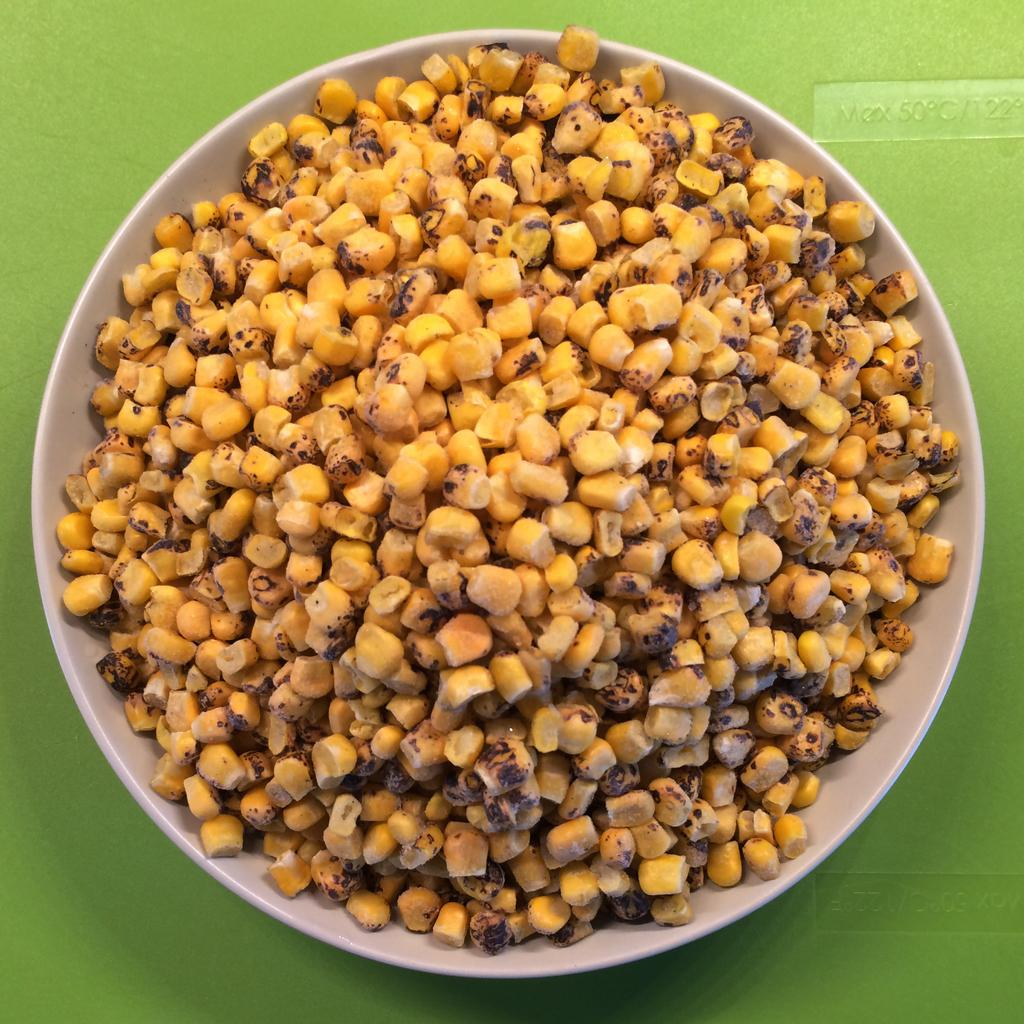What is in the white bowl in the image? There are corn seeds in a white bowl. What color is the background of the image? The background is green in color. Can you describe any text present in the image? Yes, there is text present in the image. How many oranges are on the truck in the image? There is no truck or oranges present in the image. What type of pan is being used to cook the corn seeds in the image? There is no pan or cooking activity depicted in the image; it only shows corn seeds in a white bowl. 